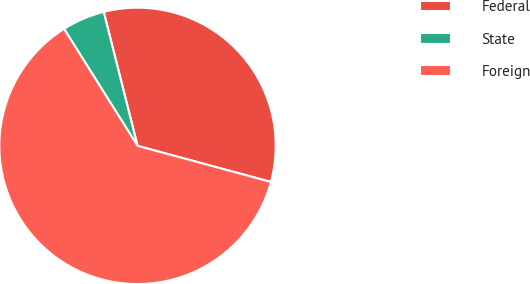Convert chart to OTSL. <chart><loc_0><loc_0><loc_500><loc_500><pie_chart><fcel>Federal<fcel>State<fcel>Foreign<nl><fcel>33.14%<fcel>4.99%<fcel>61.87%<nl></chart> 